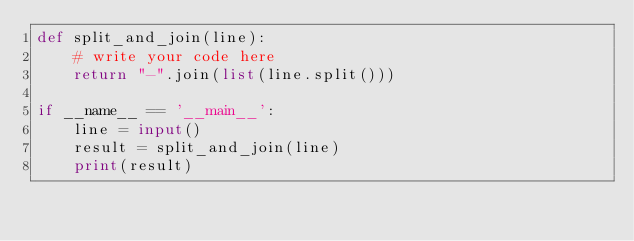<code> <loc_0><loc_0><loc_500><loc_500><_Python_>def split_and_join(line):
    # write your code here
    return "-".join(list(line.split()))

if __name__ == '__main__':
    line = input()
    result = split_and_join(line)
    print(result)

</code> 